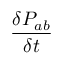Convert formula to latex. <formula><loc_0><loc_0><loc_500><loc_500>\frac { \delta P _ { a b } } { \delta t }</formula> 